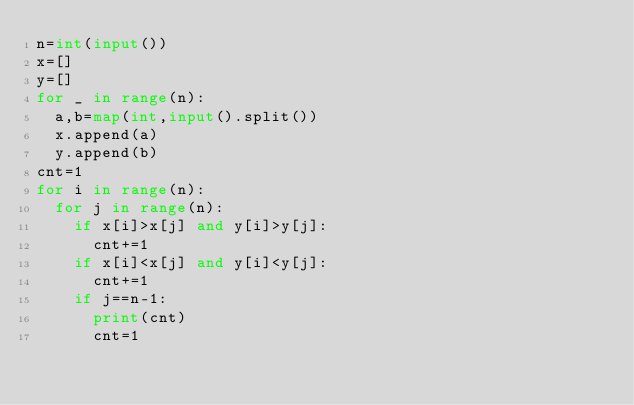<code> <loc_0><loc_0><loc_500><loc_500><_Python_>n=int(input())
x=[]
y=[]
for _ in range(n):
  a,b=map(int,input().split())
  x.append(a)
  y.append(b)
cnt=1
for i in range(n):
  for j in range(n):
    if x[i]>x[j] and y[i]>y[j]:
      cnt+=1
    if x[i]<x[j] and y[i]<y[j]:
      cnt+=1
    if j==n-1:
      print(cnt)
      cnt=1</code> 